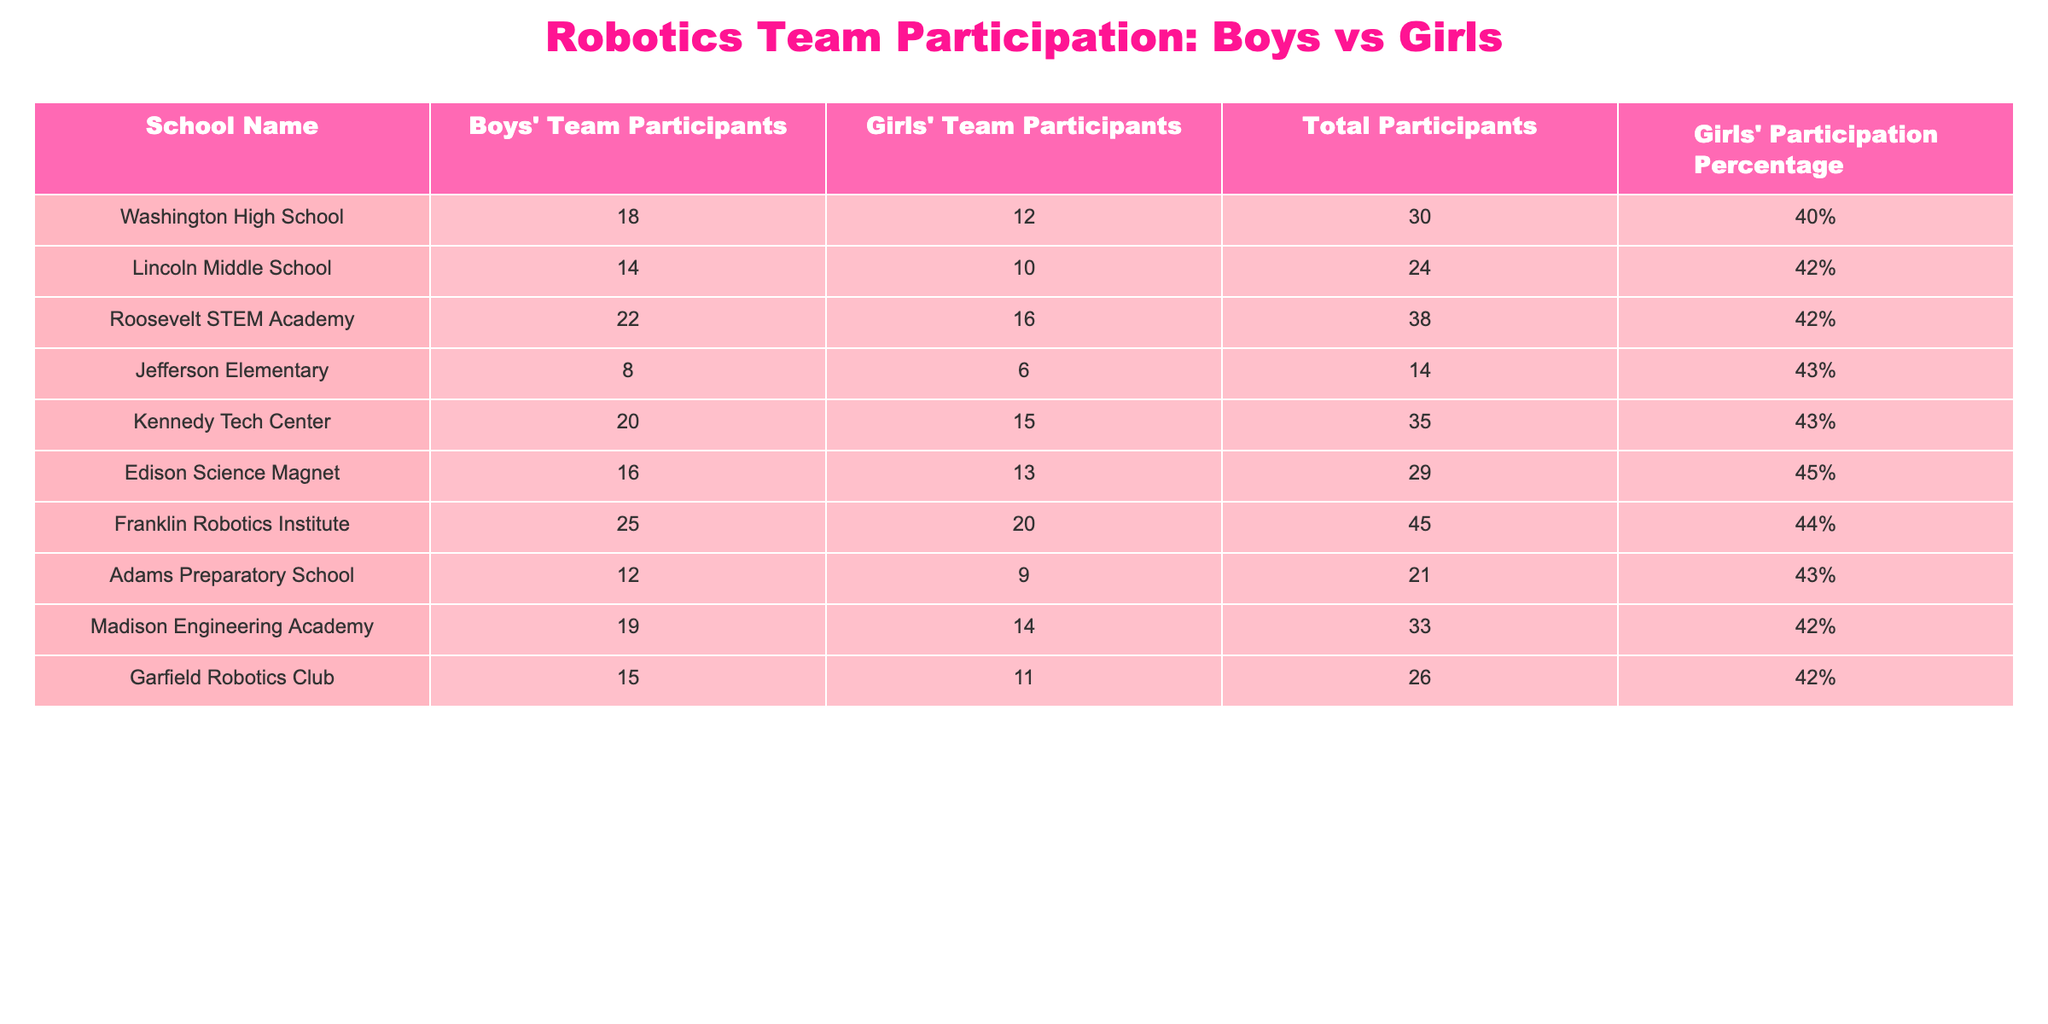What is the total number of participants in Washington High School? The table lists Washington High School with a total of 30 participants, which is explicitly stated in the "Total Participants" column.
Answer: 30 What is the girls' participation percentage at Lincoln Middle School? For Lincoln Middle School, the table shows a girls' participation percentage of 42%, which is found in the "Girls' Participation Percentage" column.
Answer: 42% Which school has the highest number of boys' team participants? Reviewing the "Boys' Team Participants" column, Franklin Robotics Institute has the highest number with 25 participants.
Answer: Franklin Robotics Institute What is the difference in the number of participants between boys' and girls' teams at Roosevelt STEM Academy? At Roosevelt STEM Academy, there are 22 boys and 16 girls. The difference is calculated as 22 - 16 = 6.
Answer: 6 Is the girls' team at Jefferson Elementary larger than the boys' team? At Jefferson Elementary, there are 6 girls and 8 boys; therefore, the girls' team is smaller.
Answer: No What is the average girls' participation percentage across all schools listed? To find the average, sum the girls' participation percentages (40 + 42 + 42 + 43 + 43 + 45 + 44 + 43 + 42 + 42 = 420) and divide by the number of schools (10), which gives 420 / 10 = 42%.
Answer: 42% Which school has a girls' participation percentage that is higher than the average? The average girls' participation percentage is 42%. The schools that exceed this percentage are Edison Science Magnet (45%), Franklin Robotics Institute (44%), and Roosevelt STEM Academy (42%).
Answer: Edison Science Magnet and Franklin Robotics Institute What is the total number of participants from all girls' teams combined? Summing up the participants from the girls' teams in each school gives (12 + 10 + 16 + 6 + 15 + 13 + 20 + 9 + 14 + 11 = 136).
Answer: 136 How many more girls participate in Edison Science Magnet than in Garfield Robotics Club? Edison Science Magnet has 13 girls and Garfield Robotics Club has 11 girls. The difference is calculated as 13 - 11 = 2.
Answer: 2 Which school has the highest percentage of girls participating, and what is that percentage? The table shows Edison Science Magnet with the highest girls' participation percentage at 45%.
Answer: Edison Science Magnet and 45% 